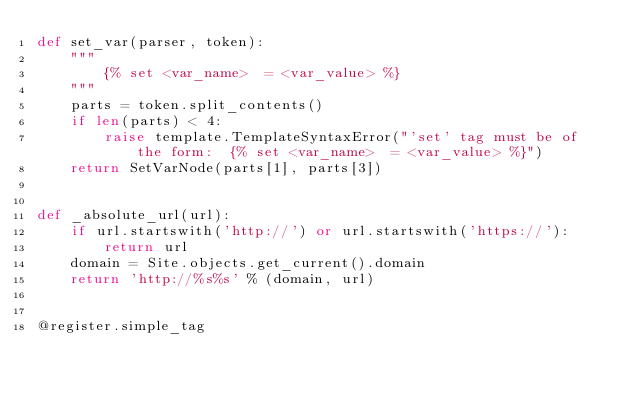<code> <loc_0><loc_0><loc_500><loc_500><_Python_>def set_var(parser, token):
    """
        {% set <var_name>  = <var_value> %}
    """
    parts = token.split_contents()
    if len(parts) < 4:
        raise template.TemplateSyntaxError("'set' tag must be of the form:  {% set <var_name>  = <var_value> %}")
    return SetVarNode(parts[1], parts[3])


def _absolute_url(url):
    if url.startswith('http://') or url.startswith('https://'):
        return url
    domain = Site.objects.get_current().domain
    return 'http://%s%s' % (domain, url)


@register.simple_tag</code> 